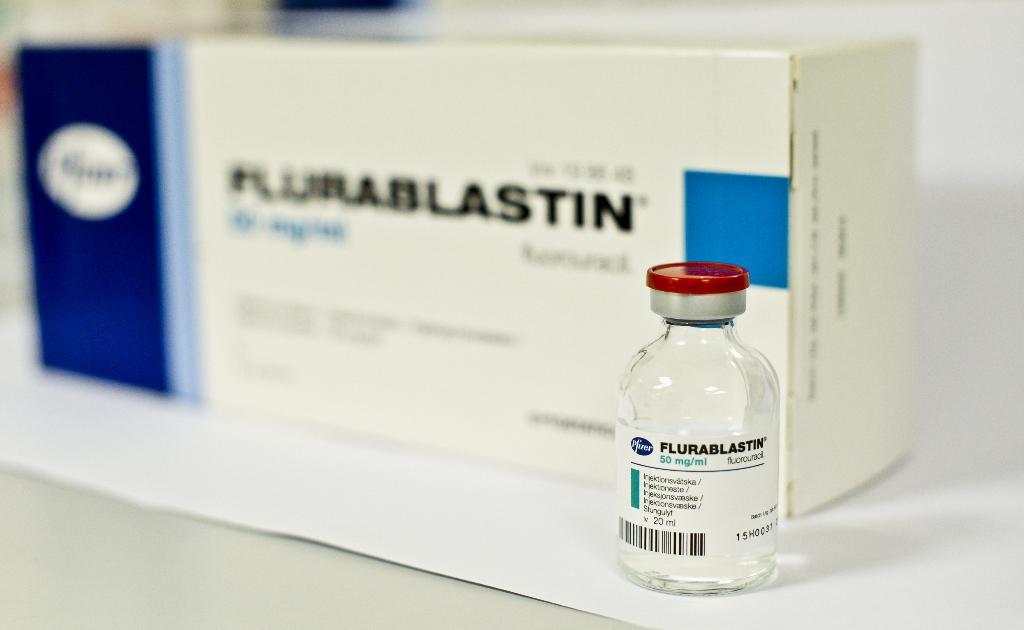What medication is this?
Offer a terse response. Flurablastin. Which big pharma company made this medication?
Provide a succinct answer. Pfizer. 